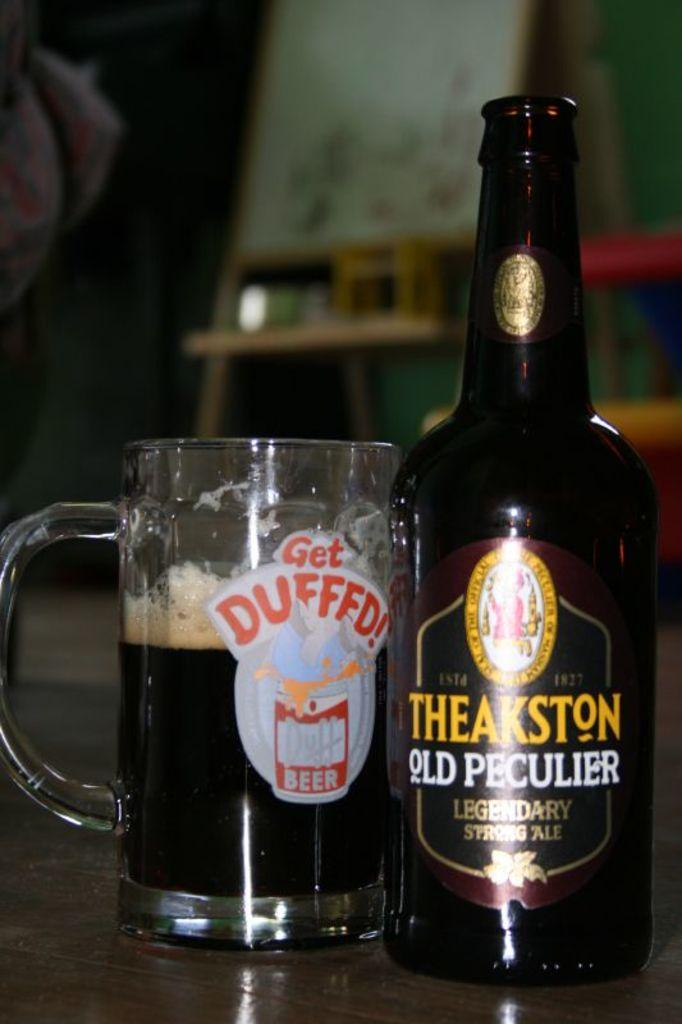Provide a one-sentence caption for the provided image. A glass that reads Get Duffed and a bottle of beer. 